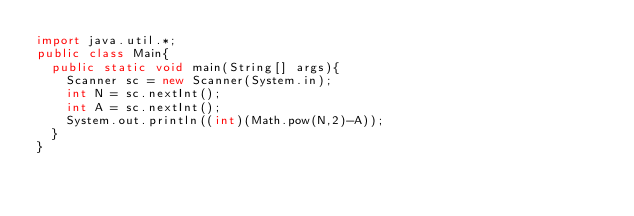<code> <loc_0><loc_0><loc_500><loc_500><_Java_>import java.util.*;
public class Main{
  public static void main(String[] args){
    Scanner sc = new Scanner(System.in);
    int N = sc.nextInt();
    int A = sc.nextInt();
    System.out.println((int)(Math.pow(N,2)-A));
  }
}
</code> 